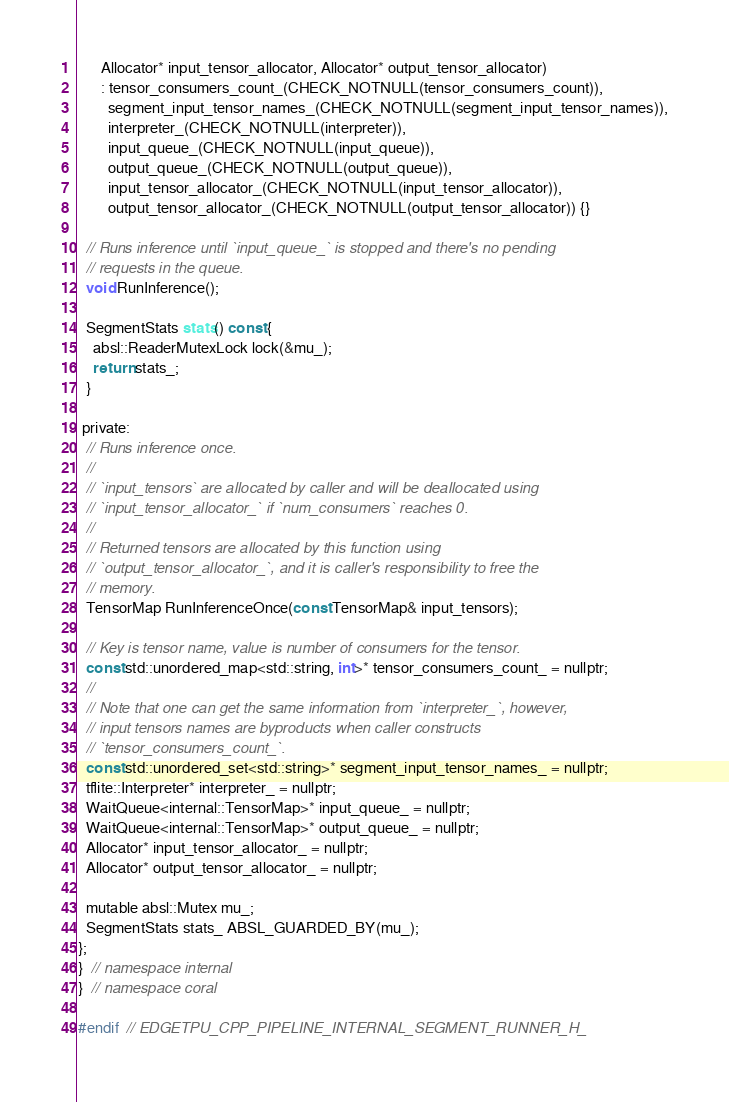<code> <loc_0><loc_0><loc_500><loc_500><_C_>      Allocator* input_tensor_allocator, Allocator* output_tensor_allocator)
      : tensor_consumers_count_(CHECK_NOTNULL(tensor_consumers_count)),
        segment_input_tensor_names_(CHECK_NOTNULL(segment_input_tensor_names)),
        interpreter_(CHECK_NOTNULL(interpreter)),
        input_queue_(CHECK_NOTNULL(input_queue)),
        output_queue_(CHECK_NOTNULL(output_queue)),
        input_tensor_allocator_(CHECK_NOTNULL(input_tensor_allocator)),
        output_tensor_allocator_(CHECK_NOTNULL(output_tensor_allocator)) {}

  // Runs inference until `input_queue_` is stopped and there's no pending
  // requests in the queue.
  void RunInference();

  SegmentStats stats() const {
    absl::ReaderMutexLock lock(&mu_);
    return stats_;
  }

 private:
  // Runs inference once.
  //
  // `input_tensors` are allocated by caller and will be deallocated using
  // `input_tensor_allocator_` if `num_consumers` reaches 0.
  //
  // Returned tensors are allocated by this function using
  // `output_tensor_allocator_`, and it is caller's responsibility to free the
  // memory.
  TensorMap RunInferenceOnce(const TensorMap& input_tensors);

  // Key is tensor name, value is number of consumers for the tensor.
  const std::unordered_map<std::string, int>* tensor_consumers_count_ = nullptr;
  //
  // Note that one can get the same information from `interpreter_`, however,
  // input tensors names are byproducts when caller constructs
  // `tensor_consumers_count_`.
  const std::unordered_set<std::string>* segment_input_tensor_names_ = nullptr;
  tflite::Interpreter* interpreter_ = nullptr;
  WaitQueue<internal::TensorMap>* input_queue_ = nullptr;
  WaitQueue<internal::TensorMap>* output_queue_ = nullptr;
  Allocator* input_tensor_allocator_ = nullptr;
  Allocator* output_tensor_allocator_ = nullptr;

  mutable absl::Mutex mu_;
  SegmentStats stats_ ABSL_GUARDED_BY(mu_);
};
}  // namespace internal
}  // namespace coral

#endif  // EDGETPU_CPP_PIPELINE_INTERNAL_SEGMENT_RUNNER_H_
</code> 